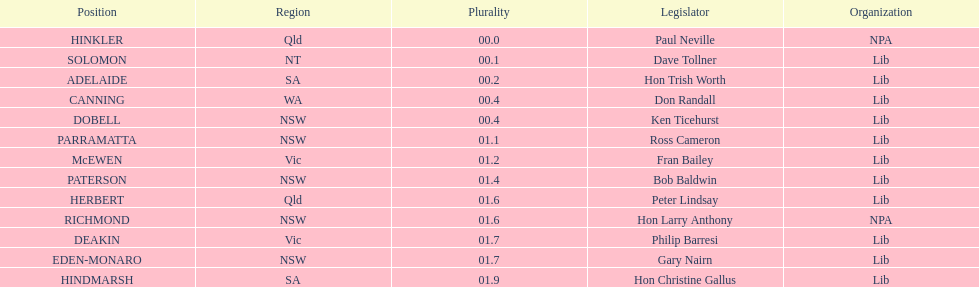What was the total majority that the dobell seat had? 00.4. 